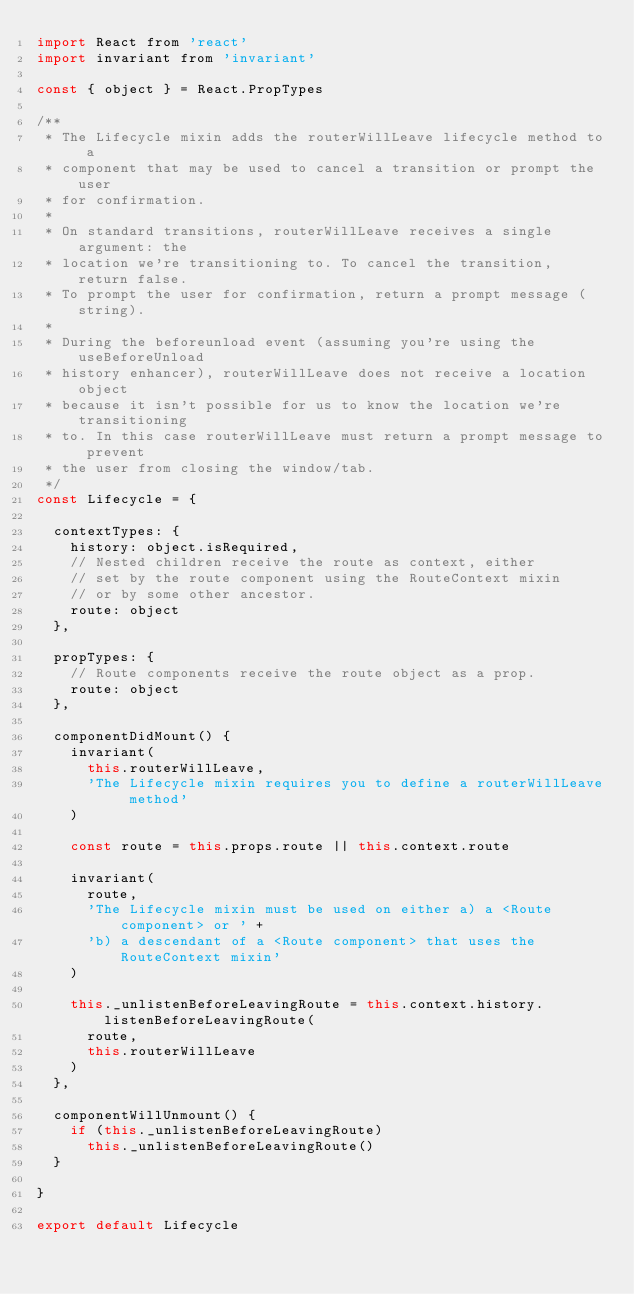Convert code to text. <code><loc_0><loc_0><loc_500><loc_500><_JavaScript_>import React from 'react'
import invariant from 'invariant'

const { object } = React.PropTypes

/**
 * The Lifecycle mixin adds the routerWillLeave lifecycle method to a
 * component that may be used to cancel a transition or prompt the user
 * for confirmation.
 *
 * On standard transitions, routerWillLeave receives a single argument: the
 * location we're transitioning to. To cancel the transition, return false.
 * To prompt the user for confirmation, return a prompt message (string).
 *
 * During the beforeunload event (assuming you're using the useBeforeUnload
 * history enhancer), routerWillLeave does not receive a location object
 * because it isn't possible for us to know the location we're transitioning
 * to. In this case routerWillLeave must return a prompt message to prevent
 * the user from closing the window/tab.
 */
const Lifecycle = {

  contextTypes: {
    history: object.isRequired,
    // Nested children receive the route as context, either
    // set by the route component using the RouteContext mixin
    // or by some other ancestor.
    route: object
  },

  propTypes: {
    // Route components receive the route object as a prop.
    route: object
  },

  componentDidMount() {
    invariant(
      this.routerWillLeave,
      'The Lifecycle mixin requires you to define a routerWillLeave method'
    )

    const route = this.props.route || this.context.route

    invariant(
      route,
      'The Lifecycle mixin must be used on either a) a <Route component> or ' +
      'b) a descendant of a <Route component> that uses the RouteContext mixin'
    )

    this._unlistenBeforeLeavingRoute = this.context.history.listenBeforeLeavingRoute(
      route,
      this.routerWillLeave
    )
  },

  componentWillUnmount() {
    if (this._unlistenBeforeLeavingRoute)
      this._unlistenBeforeLeavingRoute()
  }

}

export default Lifecycle
</code> 